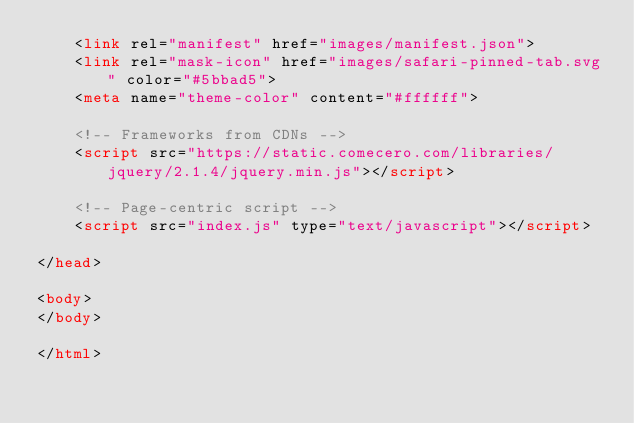Convert code to text. <code><loc_0><loc_0><loc_500><loc_500><_HTML_>    <link rel="manifest" href="images/manifest.json">
    <link rel="mask-icon" href="images/safari-pinned-tab.svg" color="#5bbad5">
    <meta name="theme-color" content="#ffffff">

    <!-- Frameworks from CDNs -->
    <script src="https://static.comecero.com/libraries/jquery/2.1.4/jquery.min.js"></script>

    <!-- Page-centric script -->
    <script src="index.js" type="text/javascript"></script>

</head>

<body>
</body>

</html>
</code> 